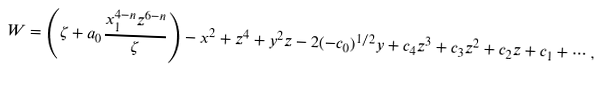Convert formula to latex. <formula><loc_0><loc_0><loc_500><loc_500>W = \left ( \zeta + a _ { 0 } \frac { x _ { 1 } ^ { 4 - n } z ^ { 6 - n } } { \zeta } \right ) - x ^ { 2 } + z ^ { 4 } + y ^ { 2 } z - 2 ( - c _ { 0 } ) ^ { 1 / 2 } y + c _ { 4 } z ^ { 3 } + c _ { 3 } z ^ { 2 } + c _ { 2 } z + c _ { 1 } + \cdots ,</formula> 